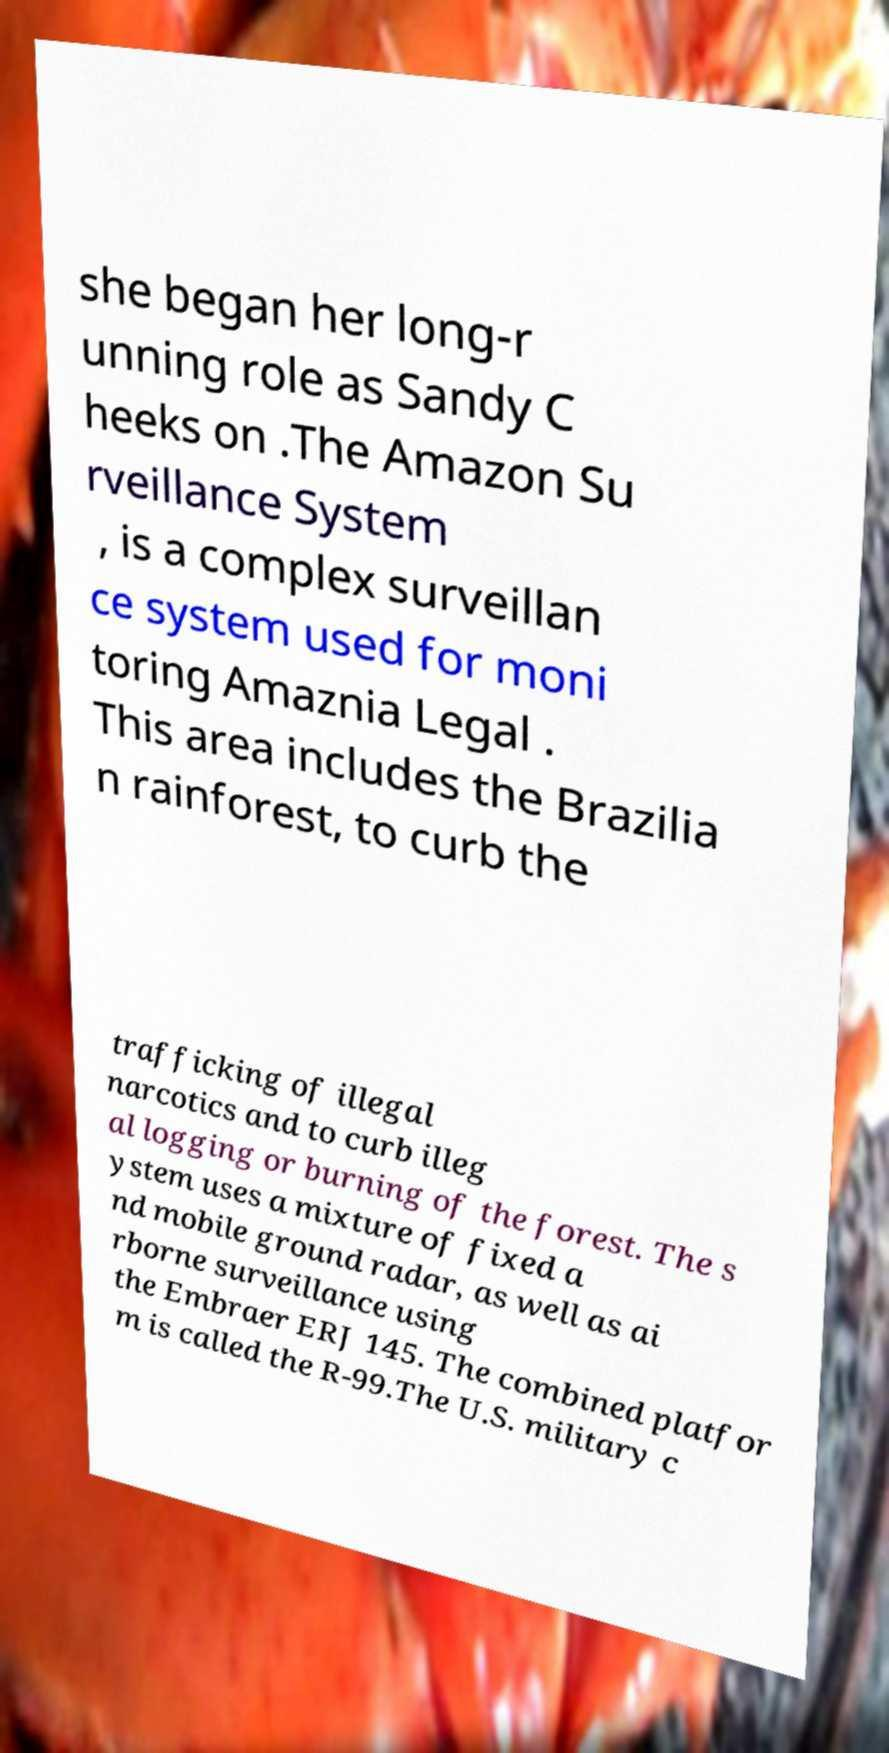Please read and relay the text visible in this image. What does it say? she began her long-r unning role as Sandy C heeks on .The Amazon Su rveillance System , is a complex surveillan ce system used for moni toring Amaznia Legal . This area includes the Brazilia n rainforest, to curb the trafficking of illegal narcotics and to curb illeg al logging or burning of the forest. The s ystem uses a mixture of fixed a nd mobile ground radar, as well as ai rborne surveillance using the Embraer ERJ 145. The combined platfor m is called the R-99.The U.S. military c 